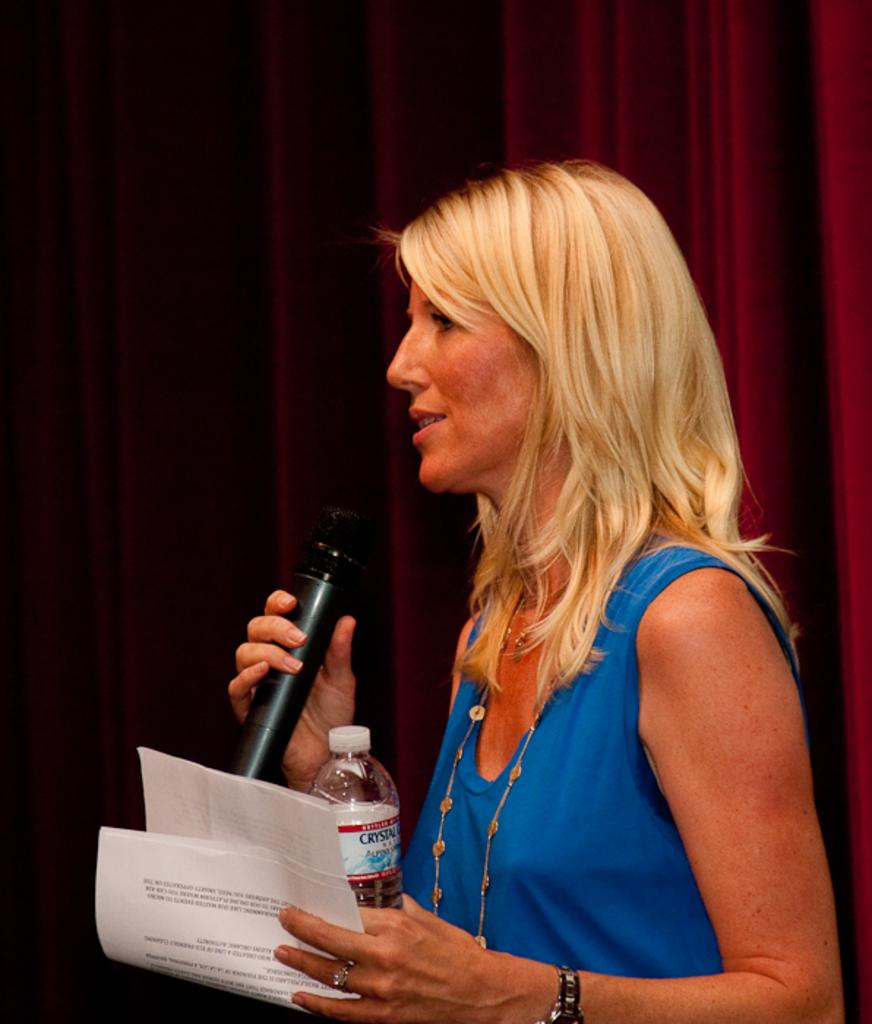Who is the main subject in the image? There is a woman in the image. What is the woman doing in the image? The woman is standing in the image. What objects is the woman holding in the image? The woman is holding a microphone, a water bottle, and papers in the image. What can be seen in the background of the image? There is a red curtain in the background of the image. What type of knee surgery is the woman undergoing in the image? There is no indication of a knee surgery or any medical procedure in the image; the woman is standing and holding various objects. 